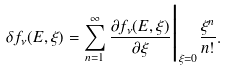Convert formula to latex. <formula><loc_0><loc_0><loc_500><loc_500>\delta f _ { \nu } ( E , \xi ) = \sum _ { n = 1 } ^ { \infty } \frac { \partial f _ { \nu } ( E , \xi ) } { \partial \xi } \Big { | } _ { \xi = 0 } \frac { \xi ^ { n } } { n ! } .</formula> 